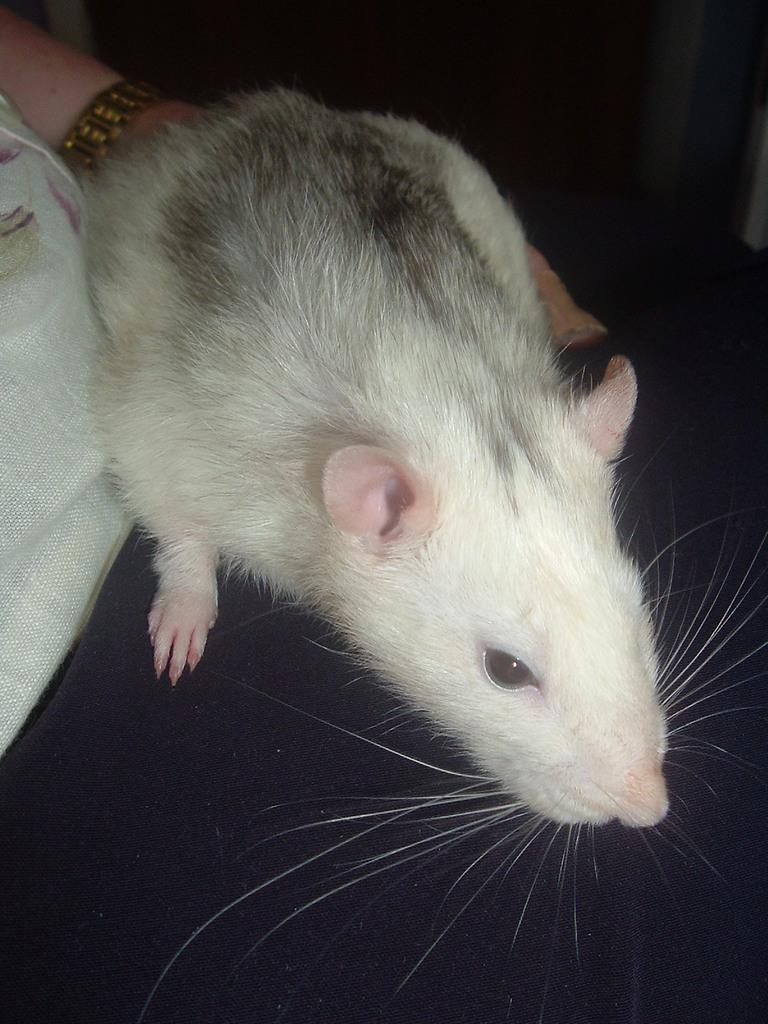What is the main subject in the center of the image? There is a rat in the center of the image. What else can be seen on the left side of the image? There is a person's hand on the left side of the image. What type of noise can be heard coming from the rat in the image? There is no indication of any noise in the image, as it only features a rat and a person's hand. 